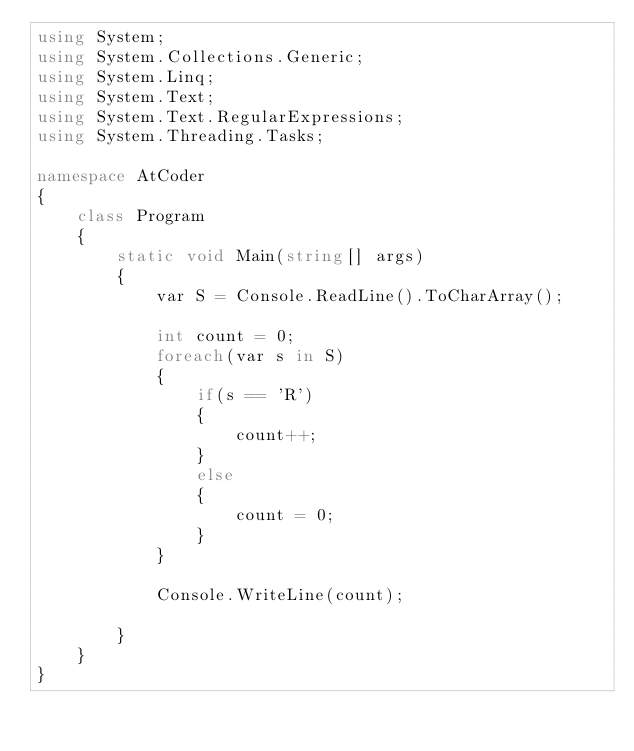Convert code to text. <code><loc_0><loc_0><loc_500><loc_500><_C#_>using System;
using System.Collections.Generic;
using System.Linq;
using System.Text;
using System.Text.RegularExpressions;
using System.Threading.Tasks;

namespace AtCoder
{
    class Program
    {
        static void Main(string[] args)
        {
            var S = Console.ReadLine().ToCharArray();

            int count = 0;
            foreach(var s in S)
            {
                if(s == 'R')
                {
                    count++;
                }
                else
                {
                    count = 0;
                }
            }

            Console.WriteLine(count);

        }
    }
}</code> 